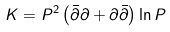<formula> <loc_0><loc_0><loc_500><loc_500>K = P ^ { 2 } \left ( \bar { \partial } \partial + \partial \bar { \partial } \right ) \ln P</formula> 